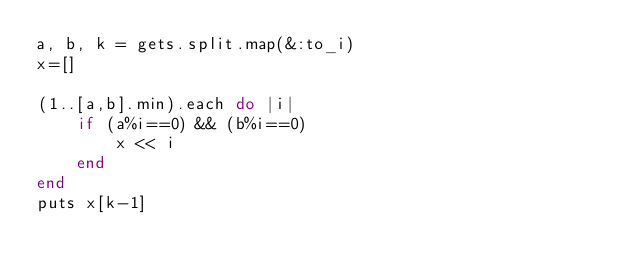<code> <loc_0><loc_0><loc_500><loc_500><_Ruby_>a, b, k = gets.split.map(&:to_i)
x=[]

(1..[a,b].min).each do |i|
    if (a%i==0) && (b%i==0)
        x << i
    end
end
puts x[k-1]
</code> 